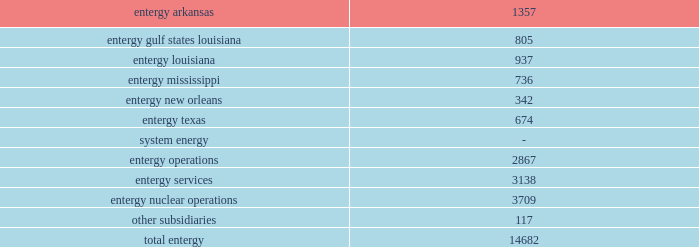Part i item 1 entergy corporation , utility operating companies , and system energy asbestos litigation ( entergy arkansas , entergy gulf states louisiana , entergy louisiana , entergy mississippi , entergy new orleans , and entergy texas ) numerous lawsuits have been filed in federal and state courts primarily in texas and louisiana , primarily by contractor employees who worked in the 1940-1980s timeframe , against entergy gulf states louisiana and entergy texas , and to a lesser extent the other utility operating companies , as premises owners of power plants , for damages caused by alleged exposure to asbestos .
Many other defendants are named in these lawsuits as well .
Currently , there are approximately 500 lawsuits involving approximately 5000 claimants .
Management believes that adequate provisions have been established to cover any exposure .
Additionally , negotiations continue with insurers to recover reimbursements .
Management believes that loss exposure has been and will continue to be handled so that the ultimate resolution of these matters will not be material , in the aggregate , to the financial position or results of operation of the utility operating companies .
Employment and labor-related proceedings ( entergy corporation , entergy arkansas , entergy gulf states louisiana , entergy louisiana , entergy mississippi , entergy new orleans , entergy texas , and system energy ) the registrant subsidiaries and other entergy subsidiaries are responding to various lawsuits in both state and federal courts and to other labor-related proceedings filed by current and former employees .
Generally , the amount of damages being sought is not specified in these proceedings .
These actions include , but are not limited to , allegations of wrongful employment actions ; wage disputes and other claims under the fair labor standards act or its state counterparts ; claims of race , gender and disability discrimination ; disputes arising under collective bargaining agreements ; unfair labor practice proceedings and other administrative proceedings before the national labor relations board ; claims of retaliation ; and claims for or regarding benefits under various entergy corporation sponsored plans .
Entergy and the registrant subsidiaries are responding to these suits and proceedings and deny liability to the claimants .
Employees employees are an integral part of entergy 2019s commitment to serving customers .
As of december 31 , 2011 , entergy subsidiaries employed 14682 people .
Utility: .
Approximately 5300 employees are represented by the international brotherhood of electrical workers , the utility workers union of america , the international brotherhood of teamsters , the united government security officers of america , and the international union , security , police , fire professionals of america. .
What percentage of total entergy's employees are part of entergy texas? 
Computations: (674 / 14682)
Answer: 0.04591. 